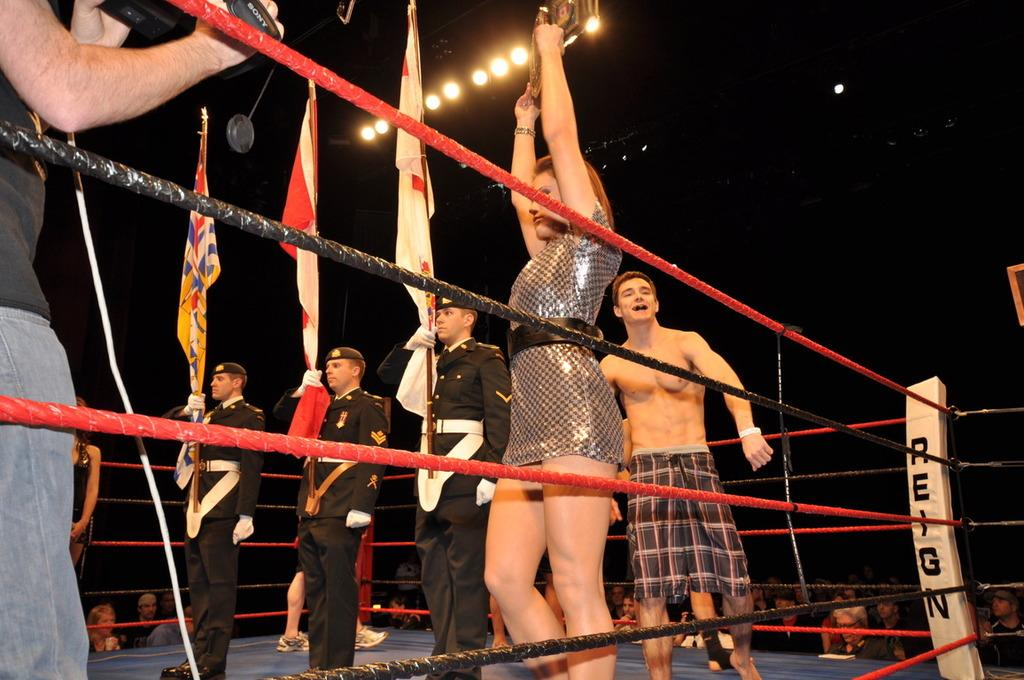<image>
Create a compact narrative representing the image presented. the word reign is on the side of a ring 